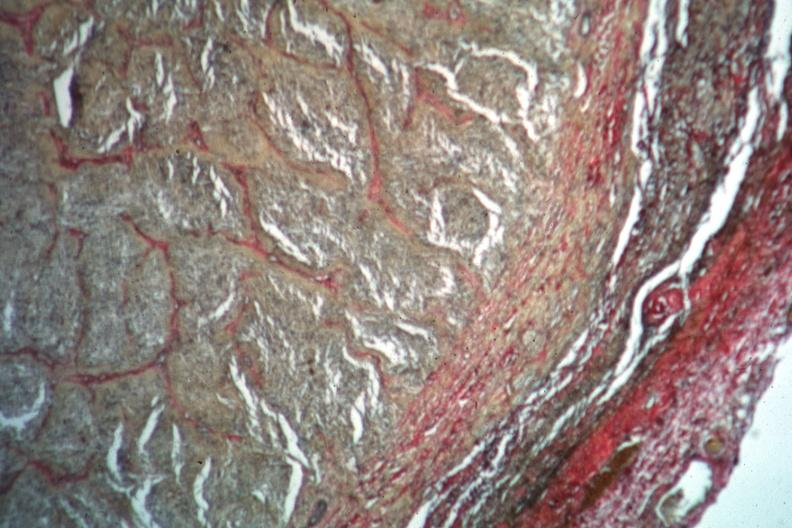s metastatic carcinoma lung present?
Answer the question using a single word or phrase. No 